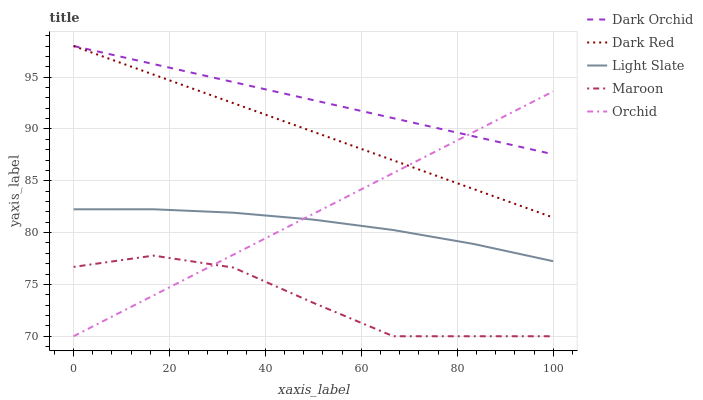Does Dark Red have the minimum area under the curve?
Answer yes or no. No. Does Dark Red have the maximum area under the curve?
Answer yes or no. No. Is Dark Red the smoothest?
Answer yes or no. No. Is Dark Red the roughest?
Answer yes or no. No. Does Dark Red have the lowest value?
Answer yes or no. No. Does Maroon have the highest value?
Answer yes or no. No. Is Light Slate less than Dark Orchid?
Answer yes or no. Yes. Is Dark Orchid greater than Maroon?
Answer yes or no. Yes. Does Light Slate intersect Dark Orchid?
Answer yes or no. No. 